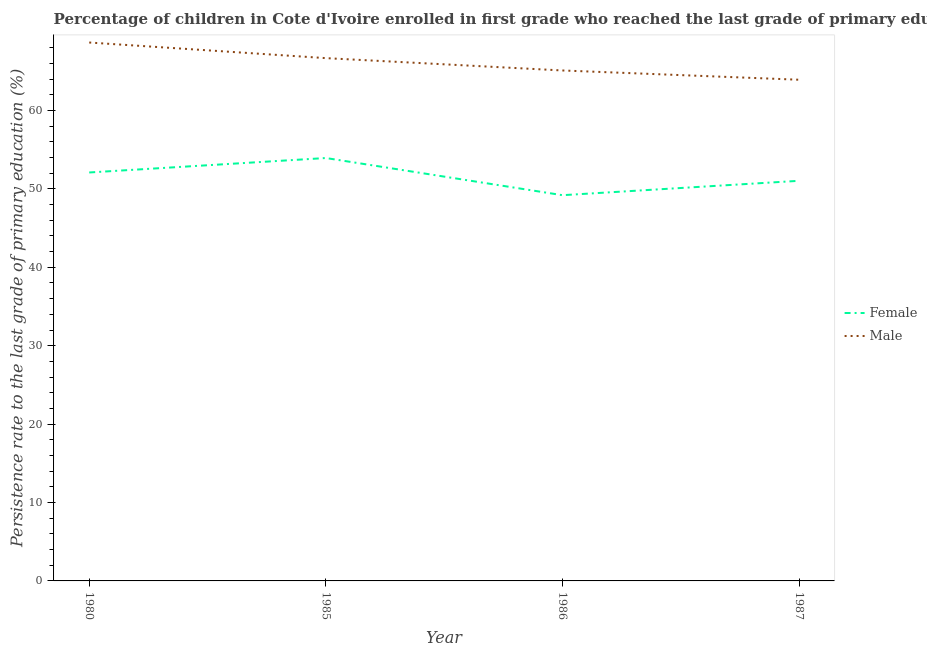How many different coloured lines are there?
Provide a short and direct response. 2. What is the persistence rate of female students in 1985?
Give a very brief answer. 53.94. Across all years, what is the maximum persistence rate of male students?
Offer a very short reply. 68.67. Across all years, what is the minimum persistence rate of male students?
Your answer should be compact. 63.93. In which year was the persistence rate of female students maximum?
Ensure brevity in your answer.  1985. What is the total persistence rate of male students in the graph?
Offer a terse response. 264.39. What is the difference between the persistence rate of male students in 1985 and that in 1987?
Offer a terse response. 2.76. What is the difference between the persistence rate of female students in 1987 and the persistence rate of male students in 1985?
Provide a short and direct response. -15.65. What is the average persistence rate of female students per year?
Provide a succinct answer. 51.57. In the year 1985, what is the difference between the persistence rate of male students and persistence rate of female students?
Your answer should be very brief. 12.74. In how many years, is the persistence rate of male students greater than 14 %?
Your answer should be compact. 4. What is the ratio of the persistence rate of male students in 1985 to that in 1986?
Make the answer very short. 1.02. Is the persistence rate of female students in 1980 less than that in 1987?
Your response must be concise. No. Is the difference between the persistence rate of male students in 1980 and 1986 greater than the difference between the persistence rate of female students in 1980 and 1986?
Offer a very short reply. Yes. What is the difference between the highest and the second highest persistence rate of female students?
Offer a very short reply. 1.84. What is the difference between the highest and the lowest persistence rate of male students?
Offer a terse response. 4.75. In how many years, is the persistence rate of male students greater than the average persistence rate of male students taken over all years?
Ensure brevity in your answer.  2. Is the sum of the persistence rate of female students in 1980 and 1987 greater than the maximum persistence rate of male students across all years?
Your answer should be very brief. Yes. What is the difference between two consecutive major ticks on the Y-axis?
Your answer should be very brief. 10. Are the values on the major ticks of Y-axis written in scientific E-notation?
Keep it short and to the point. No. What is the title of the graph?
Your answer should be compact. Percentage of children in Cote d'Ivoire enrolled in first grade who reached the last grade of primary education. What is the label or title of the Y-axis?
Give a very brief answer. Persistence rate to the last grade of primary education (%). What is the Persistence rate to the last grade of primary education (%) of Female in 1980?
Give a very brief answer. 52.1. What is the Persistence rate to the last grade of primary education (%) in Male in 1980?
Offer a terse response. 68.67. What is the Persistence rate to the last grade of primary education (%) in Female in 1985?
Your response must be concise. 53.94. What is the Persistence rate to the last grade of primary education (%) in Male in 1985?
Your answer should be compact. 66.68. What is the Persistence rate to the last grade of primary education (%) in Female in 1986?
Your answer should be very brief. 49.2. What is the Persistence rate to the last grade of primary education (%) in Male in 1986?
Give a very brief answer. 65.11. What is the Persistence rate to the last grade of primary education (%) in Female in 1987?
Offer a very short reply. 51.04. What is the Persistence rate to the last grade of primary education (%) of Male in 1987?
Make the answer very short. 63.93. Across all years, what is the maximum Persistence rate to the last grade of primary education (%) in Female?
Provide a short and direct response. 53.94. Across all years, what is the maximum Persistence rate to the last grade of primary education (%) in Male?
Offer a very short reply. 68.67. Across all years, what is the minimum Persistence rate to the last grade of primary education (%) of Female?
Your response must be concise. 49.2. Across all years, what is the minimum Persistence rate to the last grade of primary education (%) of Male?
Offer a terse response. 63.93. What is the total Persistence rate to the last grade of primary education (%) in Female in the graph?
Give a very brief answer. 206.28. What is the total Persistence rate to the last grade of primary education (%) in Male in the graph?
Provide a succinct answer. 264.39. What is the difference between the Persistence rate to the last grade of primary education (%) of Female in 1980 and that in 1985?
Your response must be concise. -1.84. What is the difference between the Persistence rate to the last grade of primary education (%) in Male in 1980 and that in 1985?
Your response must be concise. 1.99. What is the difference between the Persistence rate to the last grade of primary education (%) of Female in 1980 and that in 1986?
Provide a succinct answer. 2.9. What is the difference between the Persistence rate to the last grade of primary education (%) of Male in 1980 and that in 1986?
Your response must be concise. 3.57. What is the difference between the Persistence rate to the last grade of primary education (%) of Female in 1980 and that in 1987?
Provide a short and direct response. 1.06. What is the difference between the Persistence rate to the last grade of primary education (%) in Male in 1980 and that in 1987?
Keep it short and to the point. 4.75. What is the difference between the Persistence rate to the last grade of primary education (%) of Female in 1985 and that in 1986?
Offer a very short reply. 4.74. What is the difference between the Persistence rate to the last grade of primary education (%) in Male in 1985 and that in 1986?
Your answer should be compact. 1.57. What is the difference between the Persistence rate to the last grade of primary education (%) of Female in 1985 and that in 1987?
Give a very brief answer. 2.91. What is the difference between the Persistence rate to the last grade of primary education (%) in Male in 1985 and that in 1987?
Your answer should be compact. 2.76. What is the difference between the Persistence rate to the last grade of primary education (%) in Female in 1986 and that in 1987?
Give a very brief answer. -1.84. What is the difference between the Persistence rate to the last grade of primary education (%) of Male in 1986 and that in 1987?
Your answer should be compact. 1.18. What is the difference between the Persistence rate to the last grade of primary education (%) of Female in 1980 and the Persistence rate to the last grade of primary education (%) of Male in 1985?
Give a very brief answer. -14.58. What is the difference between the Persistence rate to the last grade of primary education (%) in Female in 1980 and the Persistence rate to the last grade of primary education (%) in Male in 1986?
Your answer should be compact. -13.01. What is the difference between the Persistence rate to the last grade of primary education (%) of Female in 1980 and the Persistence rate to the last grade of primary education (%) of Male in 1987?
Offer a very short reply. -11.83. What is the difference between the Persistence rate to the last grade of primary education (%) of Female in 1985 and the Persistence rate to the last grade of primary education (%) of Male in 1986?
Your answer should be very brief. -11.17. What is the difference between the Persistence rate to the last grade of primary education (%) in Female in 1985 and the Persistence rate to the last grade of primary education (%) in Male in 1987?
Give a very brief answer. -9.98. What is the difference between the Persistence rate to the last grade of primary education (%) of Female in 1986 and the Persistence rate to the last grade of primary education (%) of Male in 1987?
Offer a terse response. -14.73. What is the average Persistence rate to the last grade of primary education (%) of Female per year?
Provide a short and direct response. 51.57. What is the average Persistence rate to the last grade of primary education (%) of Male per year?
Make the answer very short. 66.1. In the year 1980, what is the difference between the Persistence rate to the last grade of primary education (%) of Female and Persistence rate to the last grade of primary education (%) of Male?
Provide a succinct answer. -16.58. In the year 1985, what is the difference between the Persistence rate to the last grade of primary education (%) of Female and Persistence rate to the last grade of primary education (%) of Male?
Your response must be concise. -12.74. In the year 1986, what is the difference between the Persistence rate to the last grade of primary education (%) of Female and Persistence rate to the last grade of primary education (%) of Male?
Offer a very short reply. -15.91. In the year 1987, what is the difference between the Persistence rate to the last grade of primary education (%) in Female and Persistence rate to the last grade of primary education (%) in Male?
Your answer should be compact. -12.89. What is the ratio of the Persistence rate to the last grade of primary education (%) in Female in 1980 to that in 1985?
Provide a short and direct response. 0.97. What is the ratio of the Persistence rate to the last grade of primary education (%) in Male in 1980 to that in 1985?
Your response must be concise. 1.03. What is the ratio of the Persistence rate to the last grade of primary education (%) in Female in 1980 to that in 1986?
Offer a very short reply. 1.06. What is the ratio of the Persistence rate to the last grade of primary education (%) of Male in 1980 to that in 1986?
Make the answer very short. 1.05. What is the ratio of the Persistence rate to the last grade of primary education (%) in Female in 1980 to that in 1987?
Make the answer very short. 1.02. What is the ratio of the Persistence rate to the last grade of primary education (%) in Male in 1980 to that in 1987?
Ensure brevity in your answer.  1.07. What is the ratio of the Persistence rate to the last grade of primary education (%) in Female in 1985 to that in 1986?
Offer a very short reply. 1.1. What is the ratio of the Persistence rate to the last grade of primary education (%) in Male in 1985 to that in 1986?
Your answer should be very brief. 1.02. What is the ratio of the Persistence rate to the last grade of primary education (%) in Female in 1985 to that in 1987?
Your answer should be very brief. 1.06. What is the ratio of the Persistence rate to the last grade of primary education (%) of Male in 1985 to that in 1987?
Your response must be concise. 1.04. What is the ratio of the Persistence rate to the last grade of primary education (%) in Male in 1986 to that in 1987?
Keep it short and to the point. 1.02. What is the difference between the highest and the second highest Persistence rate to the last grade of primary education (%) in Female?
Provide a short and direct response. 1.84. What is the difference between the highest and the second highest Persistence rate to the last grade of primary education (%) in Male?
Offer a very short reply. 1.99. What is the difference between the highest and the lowest Persistence rate to the last grade of primary education (%) in Female?
Make the answer very short. 4.74. What is the difference between the highest and the lowest Persistence rate to the last grade of primary education (%) of Male?
Your answer should be very brief. 4.75. 